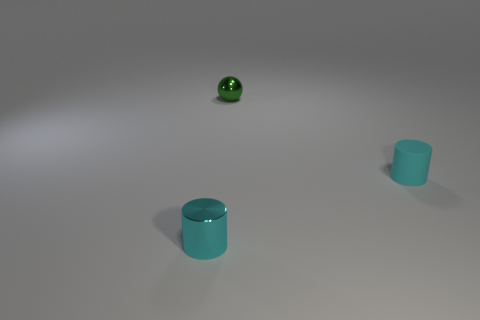How many cyan cylinders must be subtracted to get 1 cyan cylinders? 1 Subtract all purple cylinders. Subtract all blue blocks. How many cylinders are left? 2 Add 1 tiny green metal things. How many objects exist? 4 Subtract all spheres. How many objects are left? 2 Add 3 small metallic things. How many small metallic things exist? 5 Subtract 0 brown cylinders. How many objects are left? 3 Subtract all small rubber things. Subtract all large gray spheres. How many objects are left? 2 Add 1 cyan metal cylinders. How many cyan metal cylinders are left? 2 